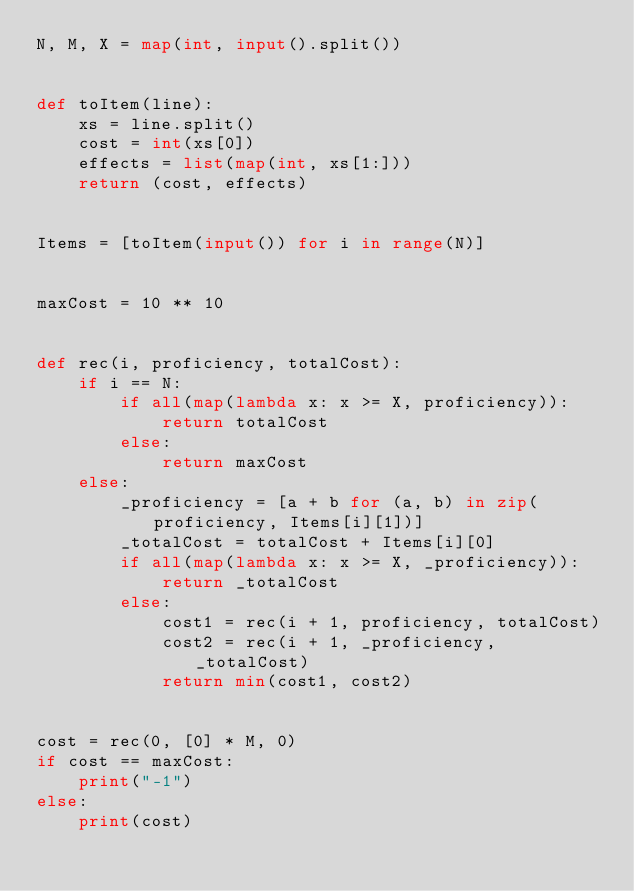Convert code to text. <code><loc_0><loc_0><loc_500><loc_500><_Python_>N, M, X = map(int, input().split())


def toItem(line):
    xs = line.split()
    cost = int(xs[0])
    effects = list(map(int, xs[1:]))
    return (cost, effects)


Items = [toItem(input()) for i in range(N)]


maxCost = 10 ** 10


def rec(i, proficiency, totalCost):
    if i == N:
        if all(map(lambda x: x >= X, proficiency)):
            return totalCost
        else:
            return maxCost
    else:
        _proficiency = [a + b for (a, b) in zip(proficiency, Items[i][1])]
        _totalCost = totalCost + Items[i][0]
        if all(map(lambda x: x >= X, _proficiency)):
            return _totalCost
        else:
            cost1 = rec(i + 1, proficiency, totalCost)
            cost2 = rec(i + 1, _proficiency, _totalCost)
            return min(cost1, cost2)


cost = rec(0, [0] * M, 0)
if cost == maxCost:
    print("-1")
else:
    print(cost)
</code> 